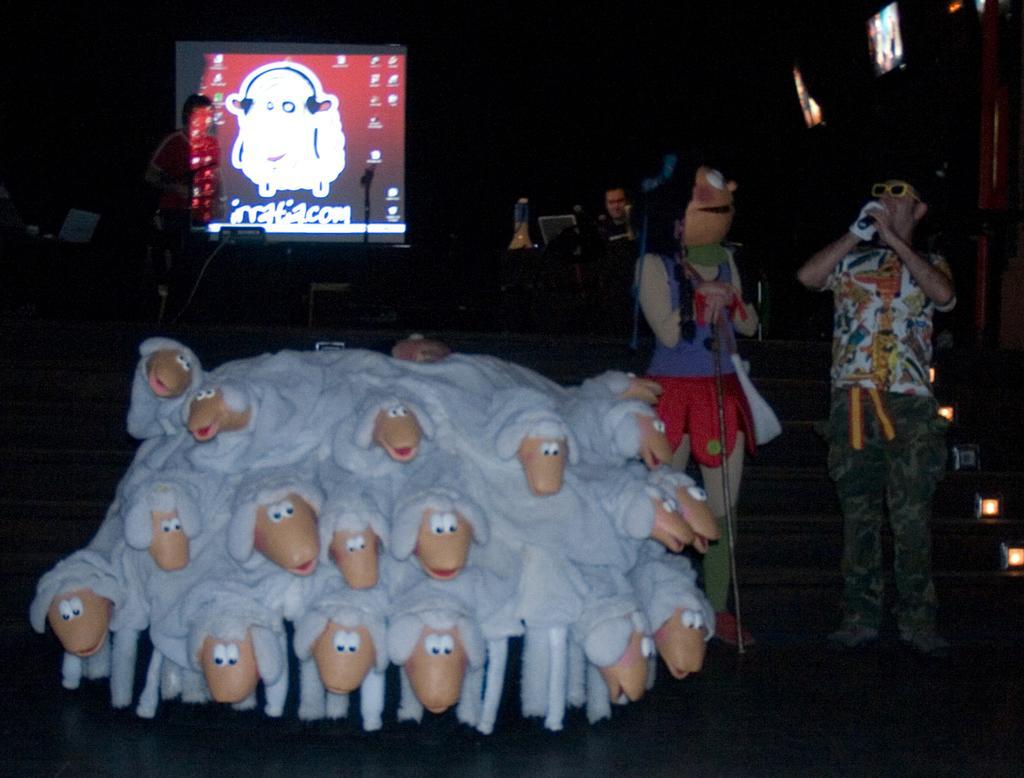Could you give a brief overview of what you see in this image? In this image there are toys of sheep's , there are four persons standing, a person in a fancy dress, there are stairs , lights, chairs, screens. 